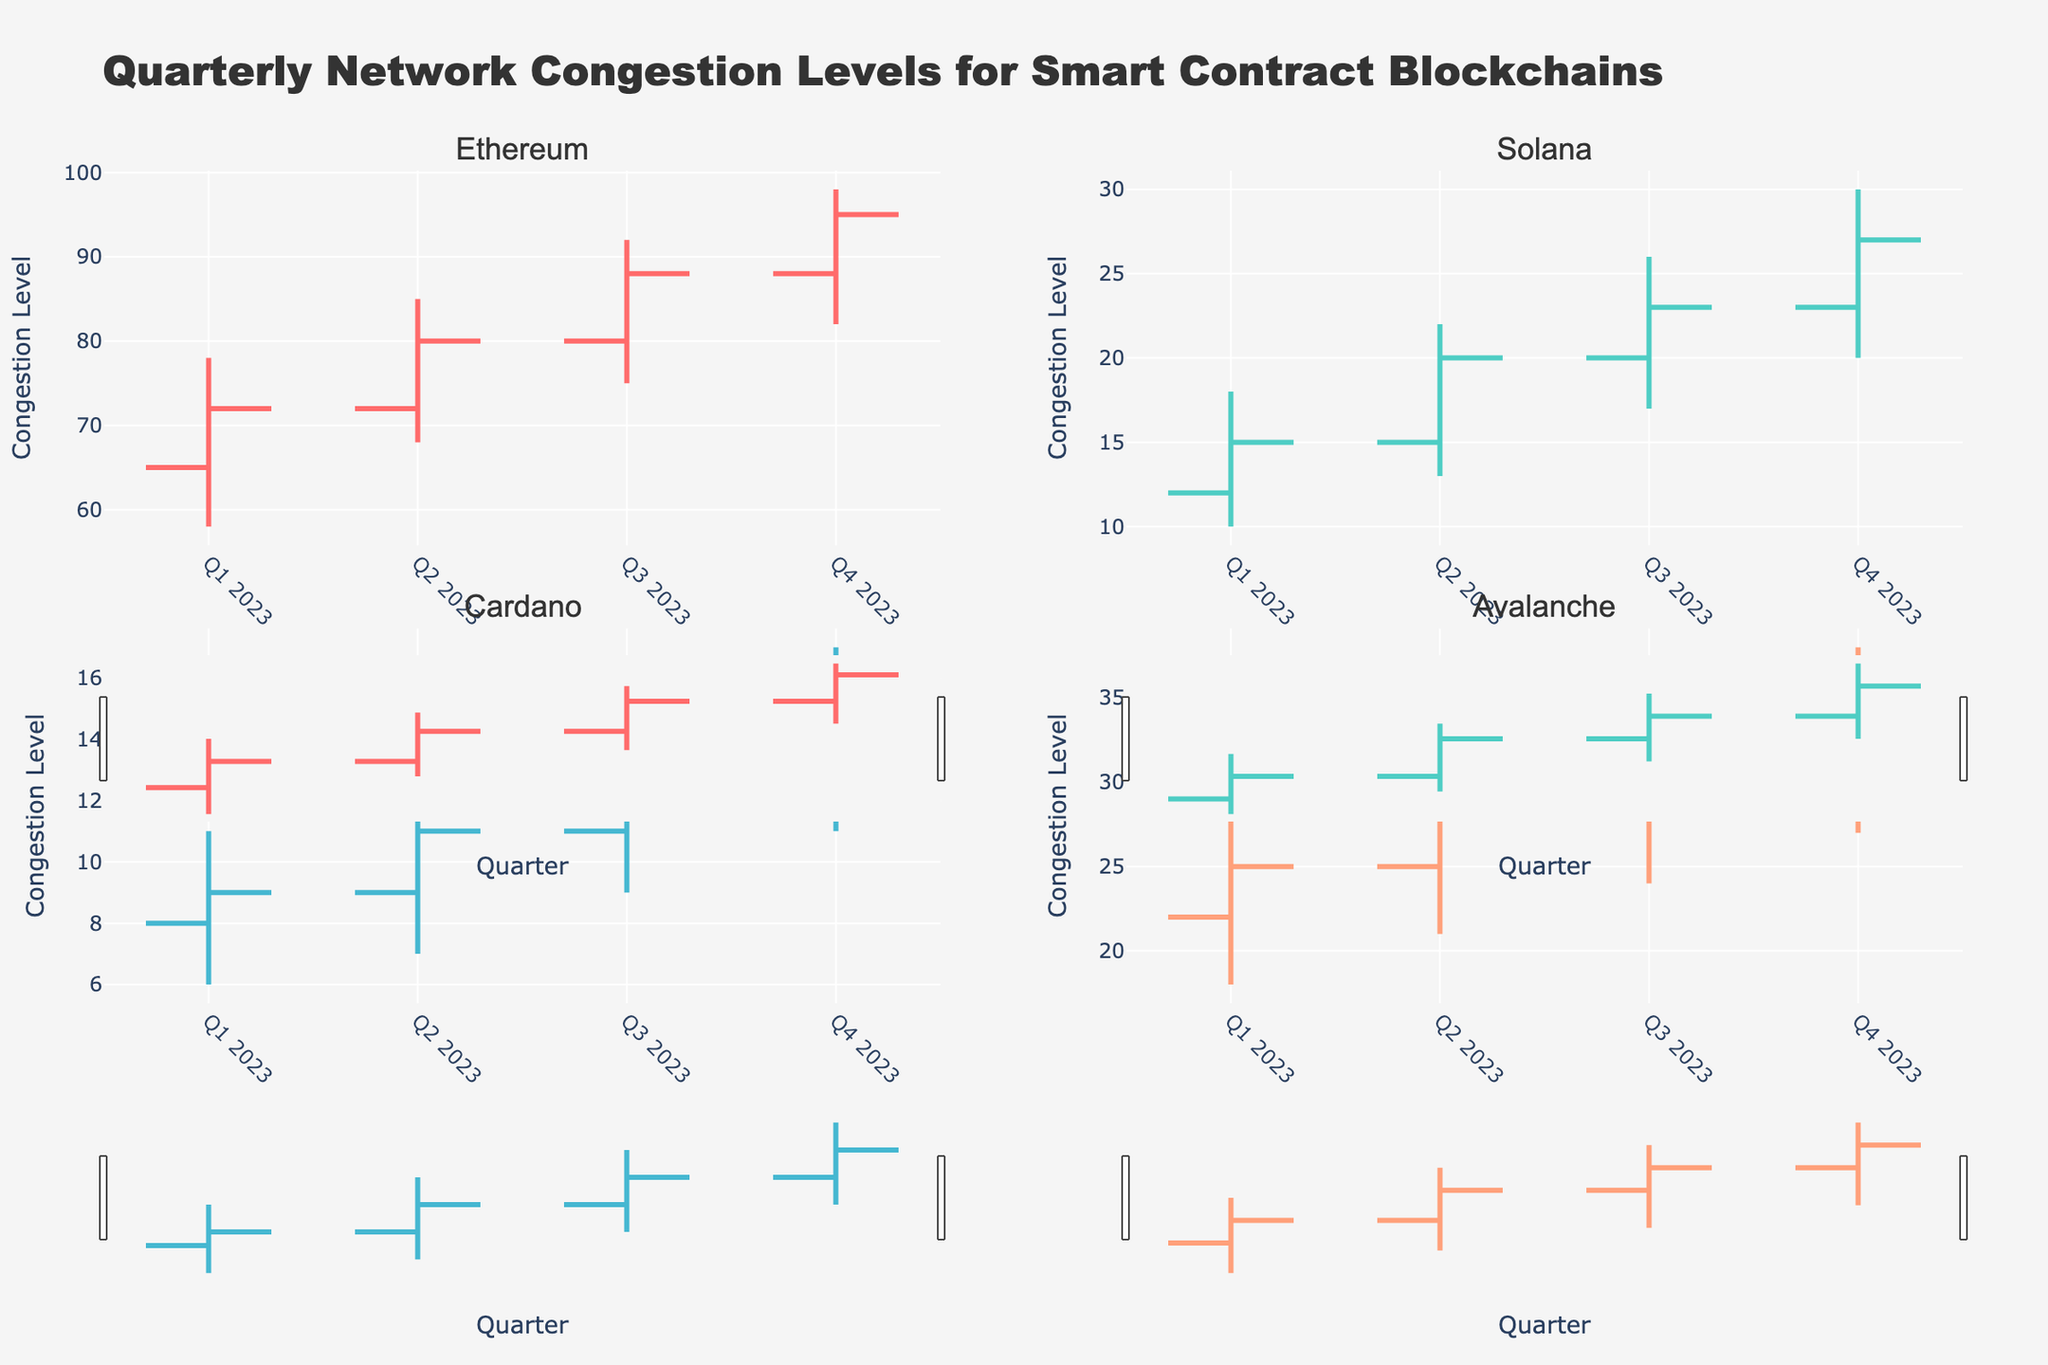What are the highest and lowest congestion levels for Ethereum in Q3 2023? Look at the "Ethereum" subplot in Q3 2023 and find the values for the highest (high) and lowest (low) congestion levels. The high value is 92 and the low value is 75.
Answer: Highest: 92, Lowest: 75 Which blockchain showed the most increase in congestion from Q1 2023 to Q4 2023? Compare the "Close" values from Q1 2023 to Q4 2023 for each blockchain. Ethereum increased from 72 to 95 (23), Solana from 15 to 27 (12), Cardano from 9 to 15 (6), and Avalanche from 25 to 35 (10). Therefore, Ethereum has the most increase.
Answer: Ethereum What was the average high congestion level for Solana across all quarters in 2023? To find the average, sum the high values for Solana for all quarters (18 + 22 + 26 + 30 = 96) and then divide by the number of quarters (96 / 4 = 24).
Answer: 24 Which quarter had the highest network congestion levels for all blockchains combined? Add the high values for all blockchains for each quarter and compare. Q4 2023: 98 (Ethereum) + 30 (Solana) + 17 (Cardano) + 38 (Avalanche) = 183. Other quarters have lower sums.
Answer: Q4 2023 In which quarter did Cardano experience its highest congestion level in 2023? Look at the high congestion levels for Cardano in each subplot and identify the highest. Q4 2023 has the peak value of 17.
Answer: Q4 2023 What is the trend of Ethereum's congestion levels from Q1 2023 to Q4 2023? Look at the "Close" values for Ethereum from Q1 2023 to Q4 2023 (72, 80, 88, 95). The values are steadily increasing each quarter.
Answer: Increasing Which blockchain had the least congestion in Q2 2023, and what was its closing congestion level? Check the "Close" values for Q2 2023 for all blockchains. Cardano has the lowest closing value of 11.
Answer: Cardano, 11 How did Avalanche's opening congestion level change from Q2 2023 to Q3 2023? Compare the "Open" values for Avalanche between Q2 2023 (25) and Q3 2023 (29). The congestion level increased by 4.
Answer: Increased by 4 